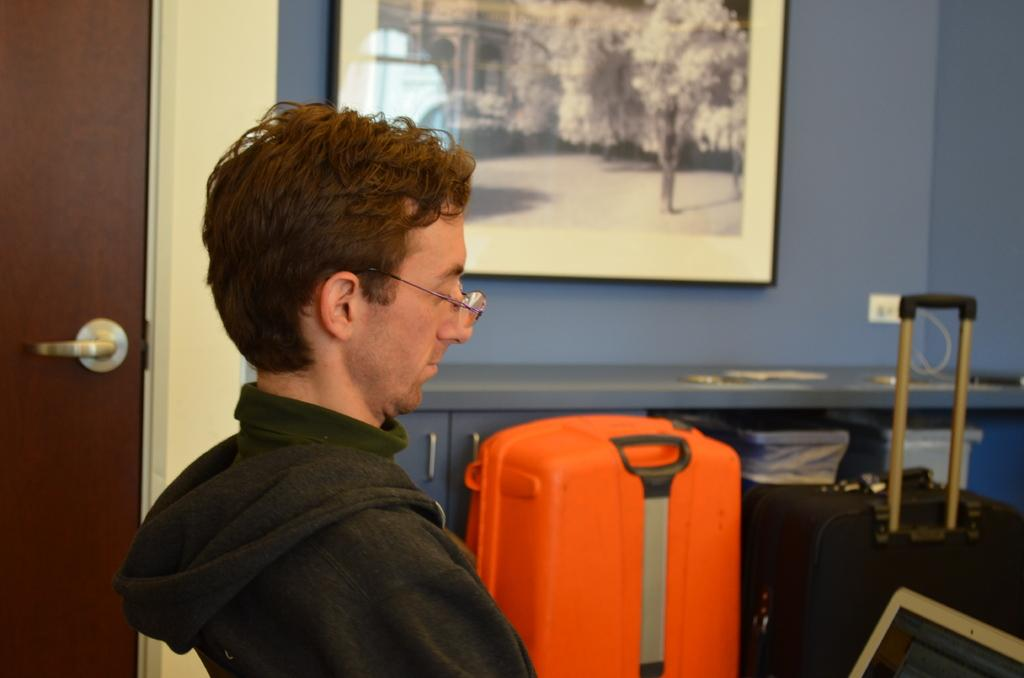What is the position of the man in the image? There is a man seated in the image. What accessory is the man wearing in the image? The man is wearing spectacles. What type of bag can be seen in the image? There is a trolley bag in the image. What is hanging on the wall in the image? There is a photo frame on the wall in the image. What type of connection can be seen in the image? There is no connection visible in the image; it only features a man, spectacles, a trolley bag, and a photo frame. How many clouds are present in the image? There are no clouds visible in the image. 